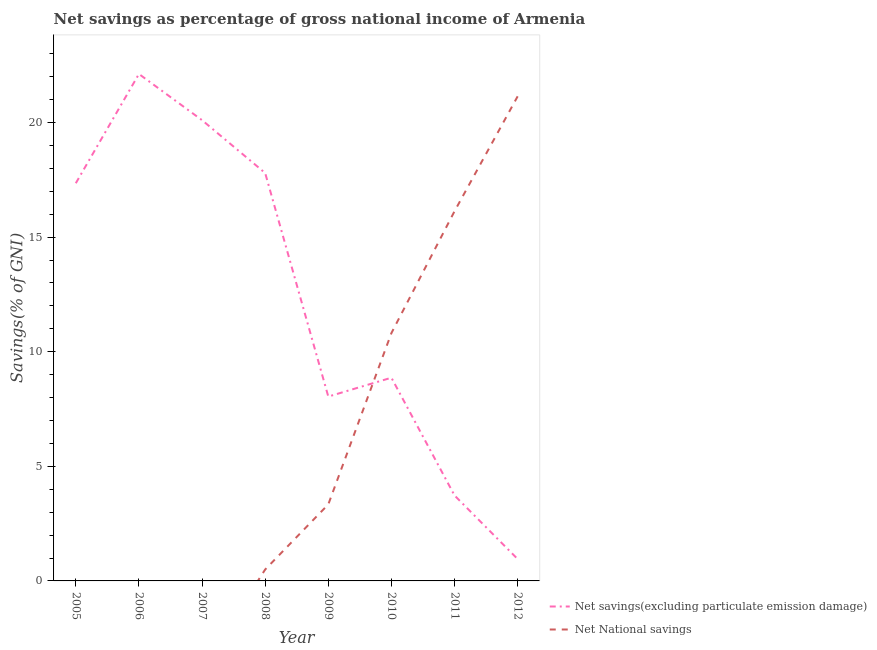Does the line corresponding to net national savings intersect with the line corresponding to net savings(excluding particulate emission damage)?
Give a very brief answer. Yes. Is the number of lines equal to the number of legend labels?
Offer a very short reply. No. What is the net savings(excluding particulate emission damage) in 2005?
Provide a short and direct response. 17.35. Across all years, what is the maximum net national savings?
Your answer should be compact. 21.14. What is the total net savings(excluding particulate emission damage) in the graph?
Make the answer very short. 98.96. What is the difference between the net national savings in 2008 and that in 2012?
Give a very brief answer. -20.64. What is the difference between the net national savings in 2011 and the net savings(excluding particulate emission damage) in 2005?
Provide a short and direct response. -1.22. What is the average net savings(excluding particulate emission damage) per year?
Ensure brevity in your answer.  12.37. In the year 2009, what is the difference between the net savings(excluding particulate emission damage) and net national savings?
Ensure brevity in your answer.  4.71. What is the ratio of the net savings(excluding particulate emission damage) in 2006 to that in 2008?
Ensure brevity in your answer.  1.24. What is the difference between the highest and the second highest net savings(excluding particulate emission damage)?
Your answer should be compact. 2.02. What is the difference between the highest and the lowest net national savings?
Keep it short and to the point. 21.14. In how many years, is the net national savings greater than the average net national savings taken over all years?
Your response must be concise. 3. Is the net savings(excluding particulate emission damage) strictly less than the net national savings over the years?
Offer a terse response. No. Are the values on the major ticks of Y-axis written in scientific E-notation?
Provide a succinct answer. No. Does the graph contain grids?
Offer a terse response. No. Where does the legend appear in the graph?
Keep it short and to the point. Bottom right. What is the title of the graph?
Provide a short and direct response. Net savings as percentage of gross national income of Armenia. What is the label or title of the X-axis?
Your answer should be compact. Year. What is the label or title of the Y-axis?
Your answer should be very brief. Savings(% of GNI). What is the Savings(% of GNI) in Net savings(excluding particulate emission damage) in 2005?
Your answer should be compact. 17.35. What is the Savings(% of GNI) of Net savings(excluding particulate emission damage) in 2006?
Your answer should be compact. 22.12. What is the Savings(% of GNI) of Net National savings in 2006?
Give a very brief answer. 0. What is the Savings(% of GNI) in Net savings(excluding particulate emission damage) in 2007?
Your answer should be very brief. 20.1. What is the Savings(% of GNI) of Net savings(excluding particulate emission damage) in 2008?
Keep it short and to the point. 17.8. What is the Savings(% of GNI) in Net National savings in 2008?
Your answer should be very brief. 0.5. What is the Savings(% of GNI) in Net savings(excluding particulate emission damage) in 2009?
Your response must be concise. 8.04. What is the Savings(% of GNI) of Net National savings in 2009?
Make the answer very short. 3.34. What is the Savings(% of GNI) of Net savings(excluding particulate emission damage) in 2010?
Offer a terse response. 8.87. What is the Savings(% of GNI) of Net National savings in 2010?
Provide a short and direct response. 10.81. What is the Savings(% of GNI) of Net savings(excluding particulate emission damage) in 2011?
Make the answer very short. 3.73. What is the Savings(% of GNI) in Net National savings in 2011?
Offer a terse response. 16.13. What is the Savings(% of GNI) in Net savings(excluding particulate emission damage) in 2012?
Offer a terse response. 0.95. What is the Savings(% of GNI) in Net National savings in 2012?
Offer a very short reply. 21.14. Across all years, what is the maximum Savings(% of GNI) of Net savings(excluding particulate emission damage)?
Ensure brevity in your answer.  22.12. Across all years, what is the maximum Savings(% of GNI) of Net National savings?
Offer a terse response. 21.14. Across all years, what is the minimum Savings(% of GNI) in Net savings(excluding particulate emission damage)?
Your answer should be compact. 0.95. What is the total Savings(% of GNI) of Net savings(excluding particulate emission damage) in the graph?
Offer a very short reply. 98.96. What is the total Savings(% of GNI) in Net National savings in the graph?
Make the answer very short. 51.92. What is the difference between the Savings(% of GNI) of Net savings(excluding particulate emission damage) in 2005 and that in 2006?
Keep it short and to the point. -4.77. What is the difference between the Savings(% of GNI) of Net savings(excluding particulate emission damage) in 2005 and that in 2007?
Keep it short and to the point. -2.75. What is the difference between the Savings(% of GNI) in Net savings(excluding particulate emission damage) in 2005 and that in 2008?
Make the answer very short. -0.45. What is the difference between the Savings(% of GNI) in Net savings(excluding particulate emission damage) in 2005 and that in 2009?
Your answer should be compact. 9.31. What is the difference between the Savings(% of GNI) in Net savings(excluding particulate emission damage) in 2005 and that in 2010?
Your answer should be very brief. 8.49. What is the difference between the Savings(% of GNI) of Net savings(excluding particulate emission damage) in 2005 and that in 2011?
Provide a short and direct response. 13.62. What is the difference between the Savings(% of GNI) of Net savings(excluding particulate emission damage) in 2005 and that in 2012?
Offer a very short reply. 16.4. What is the difference between the Savings(% of GNI) in Net savings(excluding particulate emission damage) in 2006 and that in 2007?
Offer a terse response. 2.02. What is the difference between the Savings(% of GNI) of Net savings(excluding particulate emission damage) in 2006 and that in 2008?
Offer a terse response. 4.32. What is the difference between the Savings(% of GNI) of Net savings(excluding particulate emission damage) in 2006 and that in 2009?
Keep it short and to the point. 14.07. What is the difference between the Savings(% of GNI) in Net savings(excluding particulate emission damage) in 2006 and that in 2010?
Provide a short and direct response. 13.25. What is the difference between the Savings(% of GNI) of Net savings(excluding particulate emission damage) in 2006 and that in 2011?
Offer a very short reply. 18.39. What is the difference between the Savings(% of GNI) of Net savings(excluding particulate emission damage) in 2006 and that in 2012?
Ensure brevity in your answer.  21.16. What is the difference between the Savings(% of GNI) in Net savings(excluding particulate emission damage) in 2007 and that in 2008?
Make the answer very short. 2.31. What is the difference between the Savings(% of GNI) in Net savings(excluding particulate emission damage) in 2007 and that in 2009?
Provide a succinct answer. 12.06. What is the difference between the Savings(% of GNI) of Net savings(excluding particulate emission damage) in 2007 and that in 2010?
Offer a very short reply. 11.24. What is the difference between the Savings(% of GNI) in Net savings(excluding particulate emission damage) in 2007 and that in 2011?
Offer a very short reply. 16.37. What is the difference between the Savings(% of GNI) in Net savings(excluding particulate emission damage) in 2007 and that in 2012?
Offer a terse response. 19.15. What is the difference between the Savings(% of GNI) of Net savings(excluding particulate emission damage) in 2008 and that in 2009?
Your response must be concise. 9.75. What is the difference between the Savings(% of GNI) in Net National savings in 2008 and that in 2009?
Your response must be concise. -2.84. What is the difference between the Savings(% of GNI) of Net savings(excluding particulate emission damage) in 2008 and that in 2010?
Keep it short and to the point. 8.93. What is the difference between the Savings(% of GNI) of Net National savings in 2008 and that in 2010?
Ensure brevity in your answer.  -10.32. What is the difference between the Savings(% of GNI) in Net savings(excluding particulate emission damage) in 2008 and that in 2011?
Offer a terse response. 14.07. What is the difference between the Savings(% of GNI) of Net National savings in 2008 and that in 2011?
Your response must be concise. -15.63. What is the difference between the Savings(% of GNI) in Net savings(excluding particulate emission damage) in 2008 and that in 2012?
Make the answer very short. 16.84. What is the difference between the Savings(% of GNI) of Net National savings in 2008 and that in 2012?
Offer a terse response. -20.64. What is the difference between the Savings(% of GNI) of Net savings(excluding particulate emission damage) in 2009 and that in 2010?
Keep it short and to the point. -0.82. What is the difference between the Savings(% of GNI) in Net National savings in 2009 and that in 2010?
Your answer should be compact. -7.48. What is the difference between the Savings(% of GNI) of Net savings(excluding particulate emission damage) in 2009 and that in 2011?
Your response must be concise. 4.32. What is the difference between the Savings(% of GNI) of Net National savings in 2009 and that in 2011?
Your answer should be very brief. -12.79. What is the difference between the Savings(% of GNI) of Net savings(excluding particulate emission damage) in 2009 and that in 2012?
Make the answer very short. 7.09. What is the difference between the Savings(% of GNI) in Net National savings in 2009 and that in 2012?
Keep it short and to the point. -17.8. What is the difference between the Savings(% of GNI) in Net savings(excluding particulate emission damage) in 2010 and that in 2011?
Offer a very short reply. 5.14. What is the difference between the Savings(% of GNI) in Net National savings in 2010 and that in 2011?
Offer a very short reply. -5.32. What is the difference between the Savings(% of GNI) of Net savings(excluding particulate emission damage) in 2010 and that in 2012?
Your response must be concise. 7.91. What is the difference between the Savings(% of GNI) in Net National savings in 2010 and that in 2012?
Offer a very short reply. -10.33. What is the difference between the Savings(% of GNI) in Net savings(excluding particulate emission damage) in 2011 and that in 2012?
Keep it short and to the point. 2.77. What is the difference between the Savings(% of GNI) in Net National savings in 2011 and that in 2012?
Provide a succinct answer. -5.01. What is the difference between the Savings(% of GNI) of Net savings(excluding particulate emission damage) in 2005 and the Savings(% of GNI) of Net National savings in 2008?
Your answer should be compact. 16.85. What is the difference between the Savings(% of GNI) of Net savings(excluding particulate emission damage) in 2005 and the Savings(% of GNI) of Net National savings in 2009?
Provide a short and direct response. 14.01. What is the difference between the Savings(% of GNI) of Net savings(excluding particulate emission damage) in 2005 and the Savings(% of GNI) of Net National savings in 2010?
Provide a short and direct response. 6.54. What is the difference between the Savings(% of GNI) in Net savings(excluding particulate emission damage) in 2005 and the Savings(% of GNI) in Net National savings in 2011?
Make the answer very short. 1.22. What is the difference between the Savings(% of GNI) in Net savings(excluding particulate emission damage) in 2005 and the Savings(% of GNI) in Net National savings in 2012?
Provide a succinct answer. -3.79. What is the difference between the Savings(% of GNI) in Net savings(excluding particulate emission damage) in 2006 and the Savings(% of GNI) in Net National savings in 2008?
Give a very brief answer. 21.62. What is the difference between the Savings(% of GNI) in Net savings(excluding particulate emission damage) in 2006 and the Savings(% of GNI) in Net National savings in 2009?
Make the answer very short. 18.78. What is the difference between the Savings(% of GNI) of Net savings(excluding particulate emission damage) in 2006 and the Savings(% of GNI) of Net National savings in 2010?
Provide a short and direct response. 11.3. What is the difference between the Savings(% of GNI) of Net savings(excluding particulate emission damage) in 2006 and the Savings(% of GNI) of Net National savings in 2011?
Your answer should be compact. 5.99. What is the difference between the Savings(% of GNI) in Net savings(excluding particulate emission damage) in 2006 and the Savings(% of GNI) in Net National savings in 2012?
Provide a short and direct response. 0.98. What is the difference between the Savings(% of GNI) in Net savings(excluding particulate emission damage) in 2007 and the Savings(% of GNI) in Net National savings in 2008?
Your answer should be very brief. 19.6. What is the difference between the Savings(% of GNI) in Net savings(excluding particulate emission damage) in 2007 and the Savings(% of GNI) in Net National savings in 2009?
Offer a very short reply. 16.76. What is the difference between the Savings(% of GNI) in Net savings(excluding particulate emission damage) in 2007 and the Savings(% of GNI) in Net National savings in 2010?
Make the answer very short. 9.29. What is the difference between the Savings(% of GNI) in Net savings(excluding particulate emission damage) in 2007 and the Savings(% of GNI) in Net National savings in 2011?
Your response must be concise. 3.97. What is the difference between the Savings(% of GNI) in Net savings(excluding particulate emission damage) in 2007 and the Savings(% of GNI) in Net National savings in 2012?
Offer a terse response. -1.04. What is the difference between the Savings(% of GNI) in Net savings(excluding particulate emission damage) in 2008 and the Savings(% of GNI) in Net National savings in 2009?
Provide a short and direct response. 14.46. What is the difference between the Savings(% of GNI) in Net savings(excluding particulate emission damage) in 2008 and the Savings(% of GNI) in Net National savings in 2010?
Your response must be concise. 6.98. What is the difference between the Savings(% of GNI) of Net savings(excluding particulate emission damage) in 2008 and the Savings(% of GNI) of Net National savings in 2011?
Provide a succinct answer. 1.67. What is the difference between the Savings(% of GNI) of Net savings(excluding particulate emission damage) in 2008 and the Savings(% of GNI) of Net National savings in 2012?
Keep it short and to the point. -3.35. What is the difference between the Savings(% of GNI) of Net savings(excluding particulate emission damage) in 2009 and the Savings(% of GNI) of Net National savings in 2010?
Provide a succinct answer. -2.77. What is the difference between the Savings(% of GNI) in Net savings(excluding particulate emission damage) in 2009 and the Savings(% of GNI) in Net National savings in 2011?
Your answer should be very brief. -8.09. What is the difference between the Savings(% of GNI) of Net savings(excluding particulate emission damage) in 2009 and the Savings(% of GNI) of Net National savings in 2012?
Keep it short and to the point. -13.1. What is the difference between the Savings(% of GNI) in Net savings(excluding particulate emission damage) in 2010 and the Savings(% of GNI) in Net National savings in 2011?
Provide a short and direct response. -7.26. What is the difference between the Savings(% of GNI) of Net savings(excluding particulate emission damage) in 2010 and the Savings(% of GNI) of Net National savings in 2012?
Make the answer very short. -12.28. What is the difference between the Savings(% of GNI) of Net savings(excluding particulate emission damage) in 2011 and the Savings(% of GNI) of Net National savings in 2012?
Offer a terse response. -17.41. What is the average Savings(% of GNI) in Net savings(excluding particulate emission damage) per year?
Provide a succinct answer. 12.37. What is the average Savings(% of GNI) of Net National savings per year?
Offer a terse response. 6.49. In the year 2008, what is the difference between the Savings(% of GNI) in Net savings(excluding particulate emission damage) and Savings(% of GNI) in Net National savings?
Give a very brief answer. 17.3. In the year 2009, what is the difference between the Savings(% of GNI) of Net savings(excluding particulate emission damage) and Savings(% of GNI) of Net National savings?
Offer a very short reply. 4.71. In the year 2010, what is the difference between the Savings(% of GNI) in Net savings(excluding particulate emission damage) and Savings(% of GNI) in Net National savings?
Offer a terse response. -1.95. In the year 2011, what is the difference between the Savings(% of GNI) in Net savings(excluding particulate emission damage) and Savings(% of GNI) in Net National savings?
Provide a short and direct response. -12.4. In the year 2012, what is the difference between the Savings(% of GNI) of Net savings(excluding particulate emission damage) and Savings(% of GNI) of Net National savings?
Provide a succinct answer. -20.19. What is the ratio of the Savings(% of GNI) of Net savings(excluding particulate emission damage) in 2005 to that in 2006?
Make the answer very short. 0.78. What is the ratio of the Savings(% of GNI) of Net savings(excluding particulate emission damage) in 2005 to that in 2007?
Provide a succinct answer. 0.86. What is the ratio of the Savings(% of GNI) in Net savings(excluding particulate emission damage) in 2005 to that in 2009?
Ensure brevity in your answer.  2.16. What is the ratio of the Savings(% of GNI) of Net savings(excluding particulate emission damage) in 2005 to that in 2010?
Ensure brevity in your answer.  1.96. What is the ratio of the Savings(% of GNI) of Net savings(excluding particulate emission damage) in 2005 to that in 2011?
Provide a succinct answer. 4.65. What is the ratio of the Savings(% of GNI) of Net savings(excluding particulate emission damage) in 2005 to that in 2012?
Keep it short and to the point. 18.18. What is the ratio of the Savings(% of GNI) in Net savings(excluding particulate emission damage) in 2006 to that in 2007?
Provide a succinct answer. 1.1. What is the ratio of the Savings(% of GNI) of Net savings(excluding particulate emission damage) in 2006 to that in 2008?
Your answer should be very brief. 1.24. What is the ratio of the Savings(% of GNI) of Net savings(excluding particulate emission damage) in 2006 to that in 2009?
Your answer should be compact. 2.75. What is the ratio of the Savings(% of GNI) in Net savings(excluding particulate emission damage) in 2006 to that in 2010?
Make the answer very short. 2.49. What is the ratio of the Savings(% of GNI) of Net savings(excluding particulate emission damage) in 2006 to that in 2011?
Give a very brief answer. 5.93. What is the ratio of the Savings(% of GNI) in Net savings(excluding particulate emission damage) in 2006 to that in 2012?
Give a very brief answer. 23.18. What is the ratio of the Savings(% of GNI) of Net savings(excluding particulate emission damage) in 2007 to that in 2008?
Give a very brief answer. 1.13. What is the ratio of the Savings(% of GNI) in Net savings(excluding particulate emission damage) in 2007 to that in 2009?
Keep it short and to the point. 2.5. What is the ratio of the Savings(% of GNI) of Net savings(excluding particulate emission damage) in 2007 to that in 2010?
Offer a very short reply. 2.27. What is the ratio of the Savings(% of GNI) of Net savings(excluding particulate emission damage) in 2007 to that in 2011?
Ensure brevity in your answer.  5.39. What is the ratio of the Savings(% of GNI) in Net savings(excluding particulate emission damage) in 2007 to that in 2012?
Your answer should be very brief. 21.07. What is the ratio of the Savings(% of GNI) of Net savings(excluding particulate emission damage) in 2008 to that in 2009?
Ensure brevity in your answer.  2.21. What is the ratio of the Savings(% of GNI) of Net National savings in 2008 to that in 2009?
Provide a succinct answer. 0.15. What is the ratio of the Savings(% of GNI) of Net savings(excluding particulate emission damage) in 2008 to that in 2010?
Offer a terse response. 2.01. What is the ratio of the Savings(% of GNI) of Net National savings in 2008 to that in 2010?
Keep it short and to the point. 0.05. What is the ratio of the Savings(% of GNI) in Net savings(excluding particulate emission damage) in 2008 to that in 2011?
Your answer should be very brief. 4.77. What is the ratio of the Savings(% of GNI) of Net National savings in 2008 to that in 2011?
Give a very brief answer. 0.03. What is the ratio of the Savings(% of GNI) of Net savings(excluding particulate emission damage) in 2008 to that in 2012?
Keep it short and to the point. 18.65. What is the ratio of the Savings(% of GNI) in Net National savings in 2008 to that in 2012?
Provide a short and direct response. 0.02. What is the ratio of the Savings(% of GNI) of Net savings(excluding particulate emission damage) in 2009 to that in 2010?
Keep it short and to the point. 0.91. What is the ratio of the Savings(% of GNI) in Net National savings in 2009 to that in 2010?
Ensure brevity in your answer.  0.31. What is the ratio of the Savings(% of GNI) of Net savings(excluding particulate emission damage) in 2009 to that in 2011?
Ensure brevity in your answer.  2.16. What is the ratio of the Savings(% of GNI) of Net National savings in 2009 to that in 2011?
Your answer should be compact. 0.21. What is the ratio of the Savings(% of GNI) of Net savings(excluding particulate emission damage) in 2009 to that in 2012?
Give a very brief answer. 8.43. What is the ratio of the Savings(% of GNI) of Net National savings in 2009 to that in 2012?
Provide a short and direct response. 0.16. What is the ratio of the Savings(% of GNI) in Net savings(excluding particulate emission damage) in 2010 to that in 2011?
Provide a short and direct response. 2.38. What is the ratio of the Savings(% of GNI) in Net National savings in 2010 to that in 2011?
Provide a short and direct response. 0.67. What is the ratio of the Savings(% of GNI) of Net savings(excluding particulate emission damage) in 2010 to that in 2012?
Offer a very short reply. 9.29. What is the ratio of the Savings(% of GNI) of Net National savings in 2010 to that in 2012?
Your answer should be very brief. 0.51. What is the ratio of the Savings(% of GNI) in Net savings(excluding particulate emission damage) in 2011 to that in 2012?
Provide a succinct answer. 3.91. What is the ratio of the Savings(% of GNI) of Net National savings in 2011 to that in 2012?
Keep it short and to the point. 0.76. What is the difference between the highest and the second highest Savings(% of GNI) in Net savings(excluding particulate emission damage)?
Provide a short and direct response. 2.02. What is the difference between the highest and the second highest Savings(% of GNI) of Net National savings?
Give a very brief answer. 5.01. What is the difference between the highest and the lowest Savings(% of GNI) in Net savings(excluding particulate emission damage)?
Offer a terse response. 21.16. What is the difference between the highest and the lowest Savings(% of GNI) in Net National savings?
Make the answer very short. 21.14. 